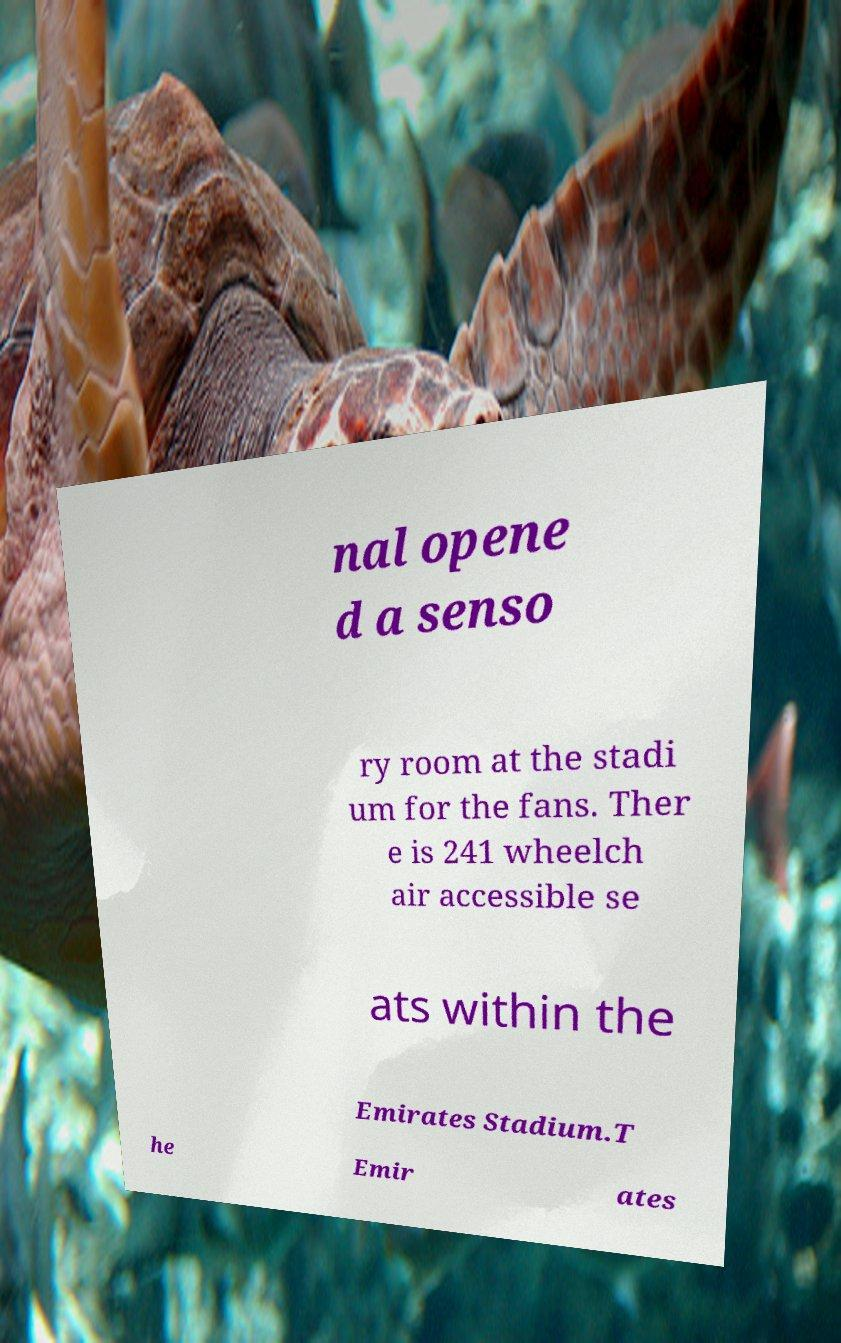I need the written content from this picture converted into text. Can you do that? nal opene d a senso ry room at the stadi um for the fans. Ther e is 241 wheelch air accessible se ats within the Emirates Stadium.T he Emir ates 